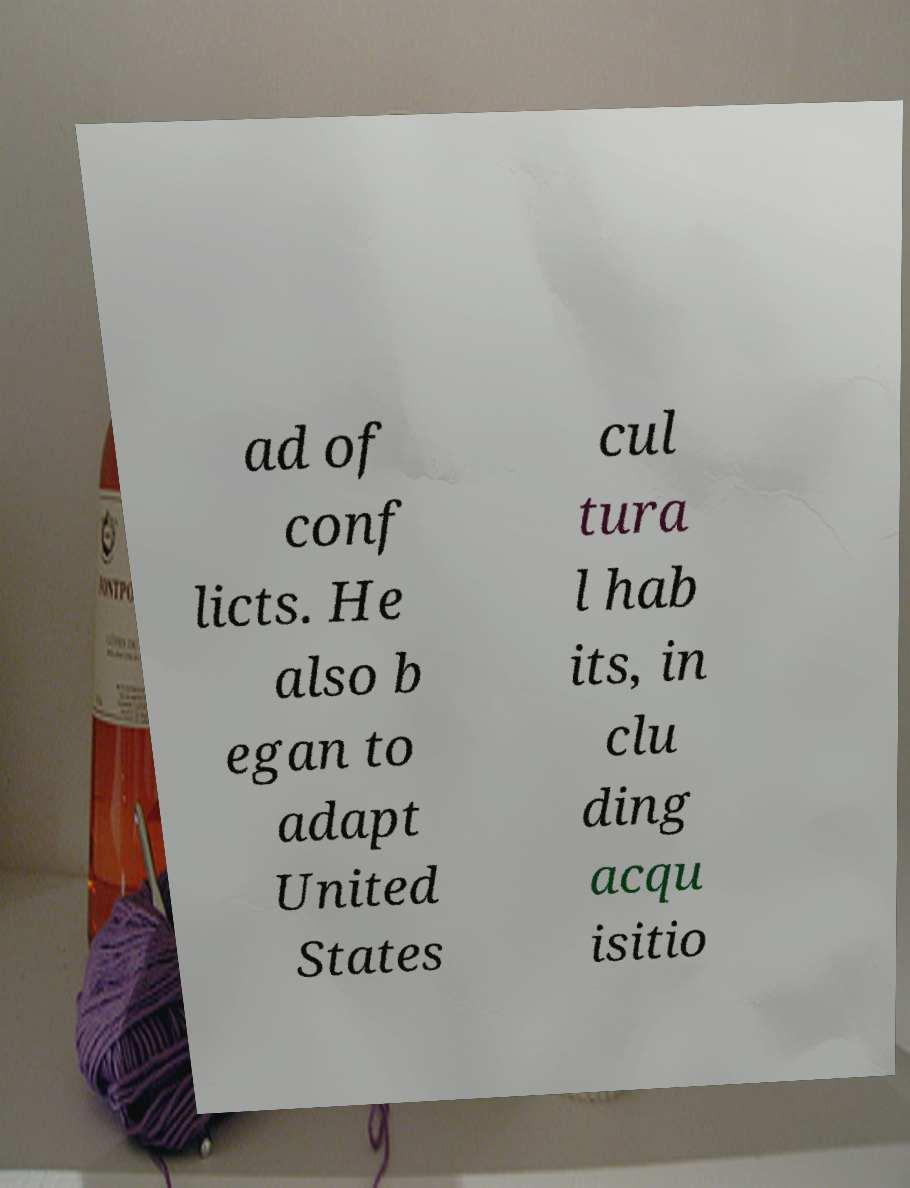Can you read and provide the text displayed in the image?This photo seems to have some interesting text. Can you extract and type it out for me? ad of conf licts. He also b egan to adapt United States cul tura l hab its, in clu ding acqu isitio 